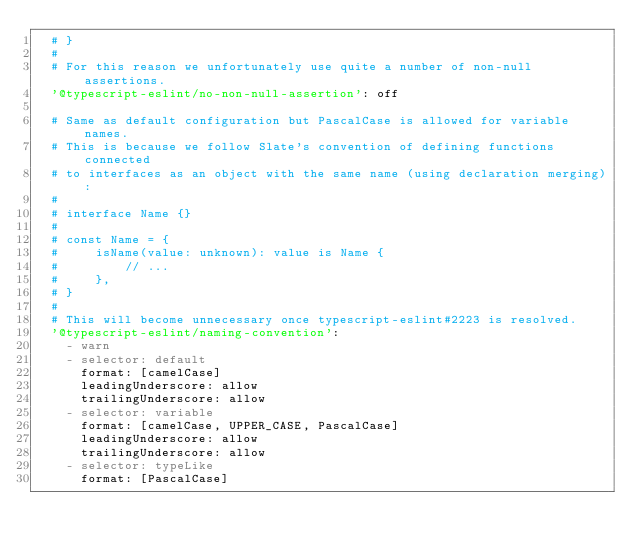Convert code to text. <code><loc_0><loc_0><loc_500><loc_500><_YAML_>  # }
  #
  # For this reason we unfortunately use quite a number of non-null assertions.
  '@typescript-eslint/no-non-null-assertion': off

  # Same as default configuration but PascalCase is allowed for variable names.
  # This is because we follow Slate's convention of defining functions connected
  # to interfaces as an object with the same name (using declaration merging):
  #
  # interface Name {}
  #
  # const Name = {
  #     isName(value: unknown): value is Name {
  #         // ...
  #     },
  # }
  #
  # This will become unnecessary once typescript-eslint#2223 is resolved.
  '@typescript-eslint/naming-convention':
    - warn
    - selector: default
      format: [camelCase]
      leadingUnderscore: allow
      trailingUnderscore: allow
    - selector: variable
      format: [camelCase, UPPER_CASE, PascalCase]
      leadingUnderscore: allow
      trailingUnderscore: allow
    - selector: typeLike
      format: [PascalCase]
</code> 